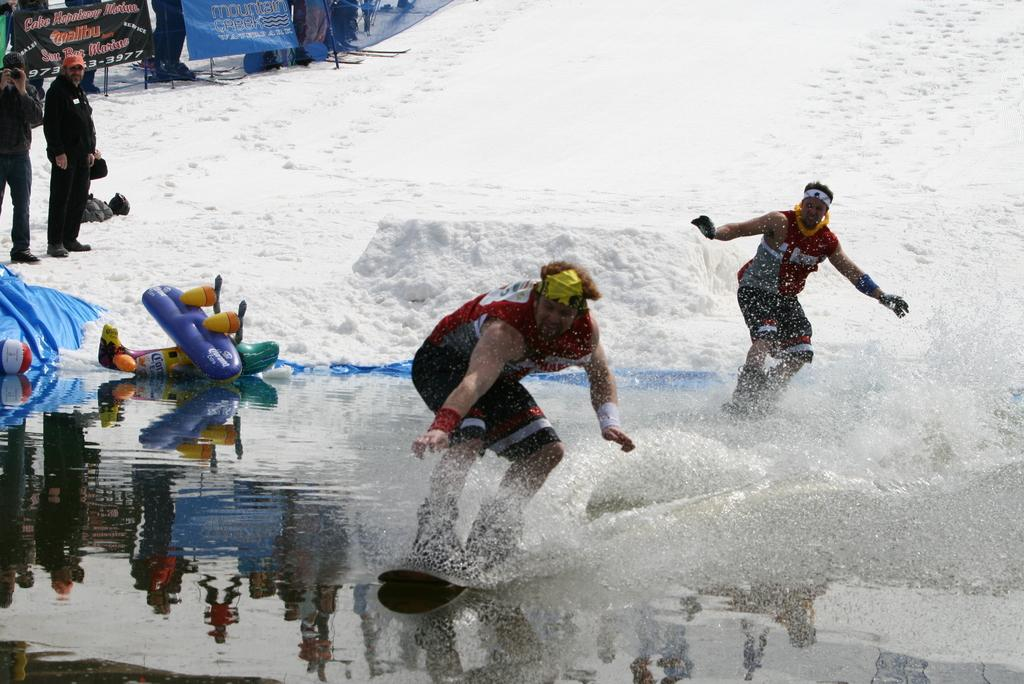What are the two persons in the foreground of the image doing? The two persons in the foreground of the image are surfing on the water. What can be seen in the background of the image? There are two persons standing on the snow in the background. What colors are the banners in the background? The banners in the background are in black and blue color. Can you see a loaf of bread being used by the surfers in the image? There is no loaf of bread present in the image. What type of watch is the giraffe wearing in the image? There are no giraffes present in the image. 